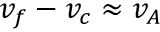Convert formula to latex. <formula><loc_0><loc_0><loc_500><loc_500>v _ { f } - v _ { c } \approx v _ { A }</formula> 